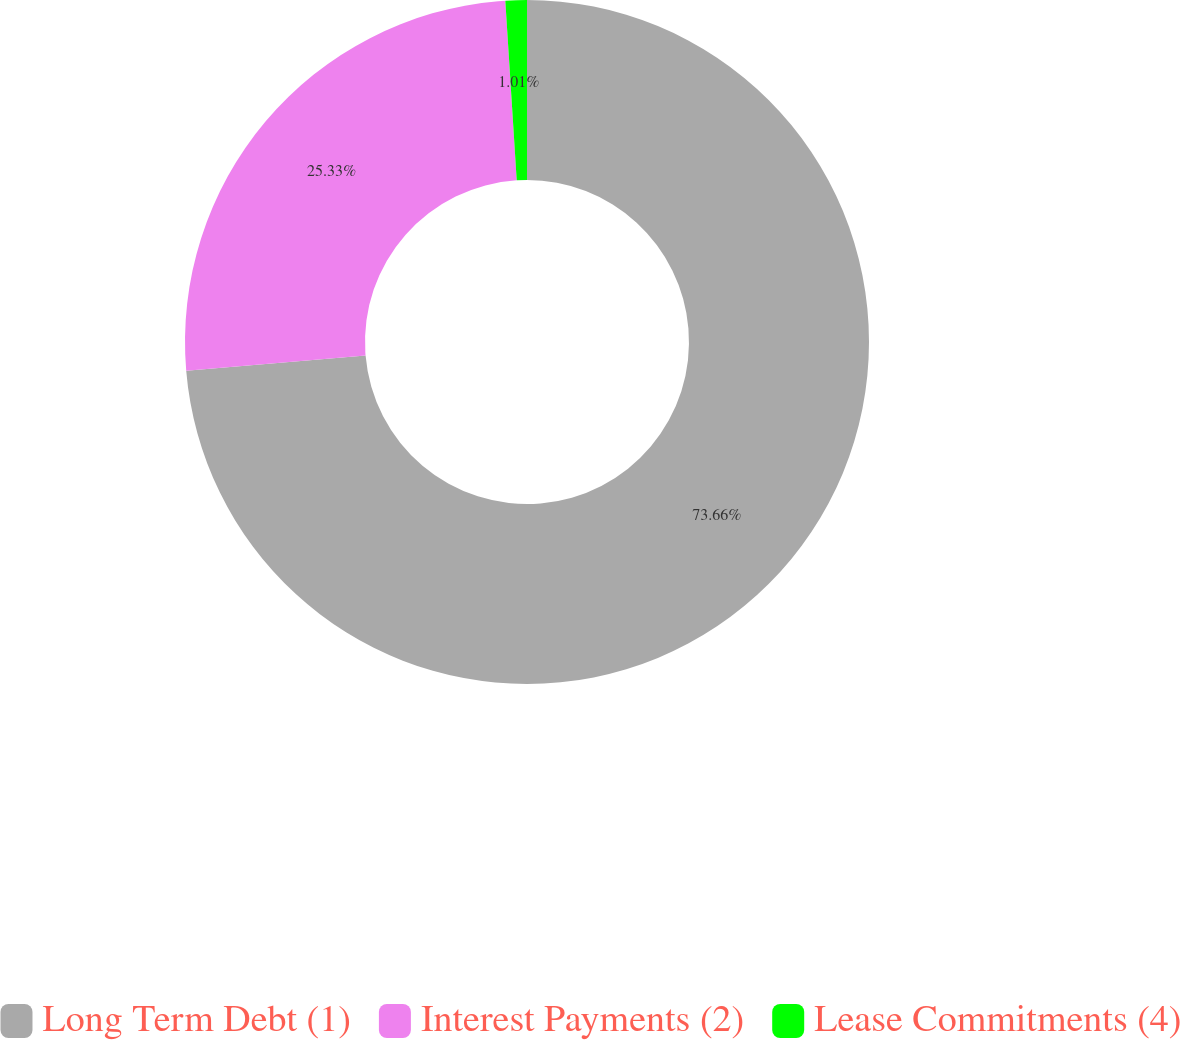Convert chart to OTSL. <chart><loc_0><loc_0><loc_500><loc_500><pie_chart><fcel>Long Term Debt (1)<fcel>Interest Payments (2)<fcel>Lease Commitments (4)<nl><fcel>73.66%<fcel>25.33%<fcel>1.01%<nl></chart> 